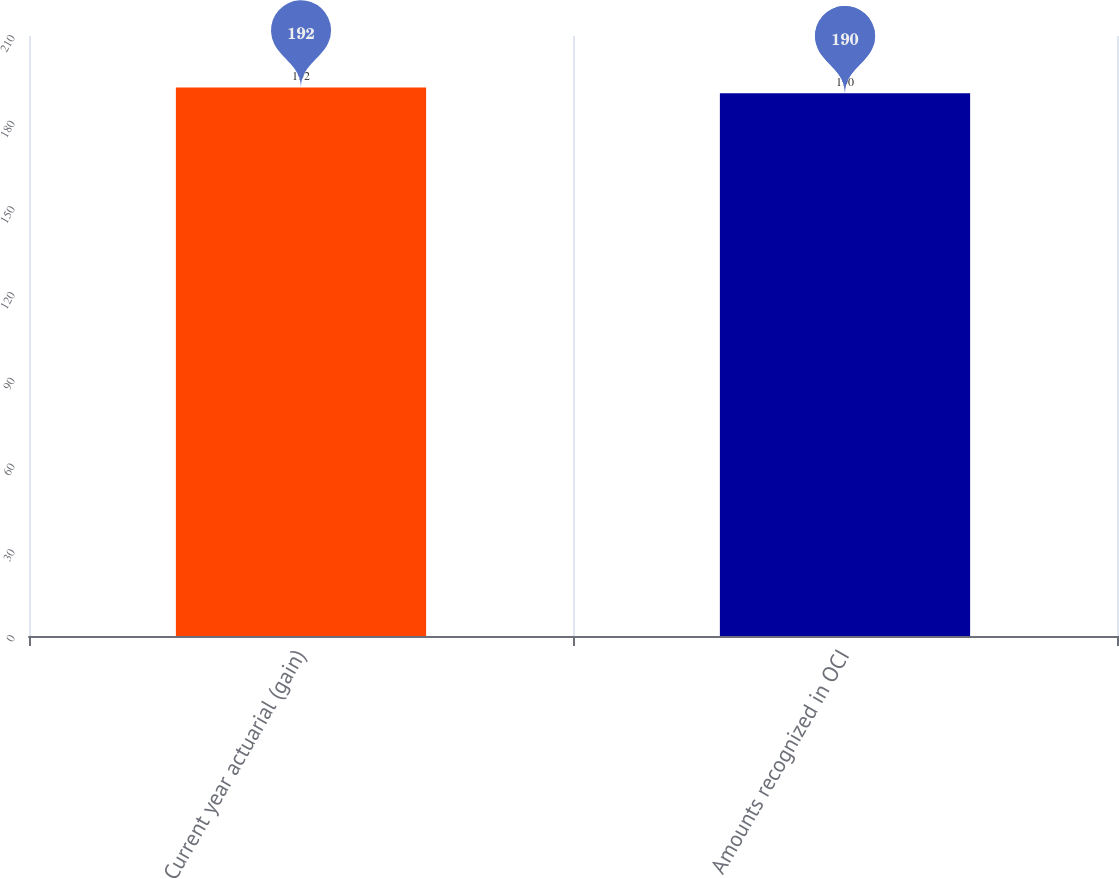Convert chart. <chart><loc_0><loc_0><loc_500><loc_500><bar_chart><fcel>Current year actuarial (gain)<fcel>Amounts recognized in OCI<nl><fcel>192<fcel>190<nl></chart> 